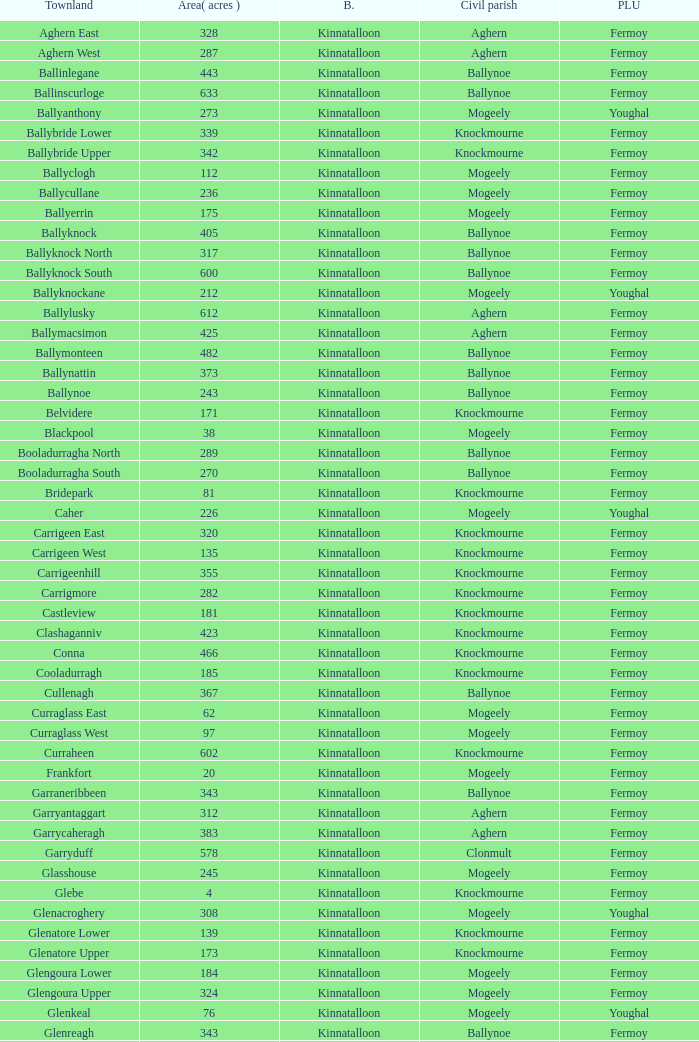Name the area for civil parish ballynoe and killasseragh 340.0. Give me the full table as a dictionary. {'header': ['Townland', 'Area( acres )', 'B.', 'Civil parish', 'PLU'], 'rows': [['Aghern East', '328', 'Kinnatalloon', 'Aghern', 'Fermoy'], ['Aghern West', '287', 'Kinnatalloon', 'Aghern', 'Fermoy'], ['Ballinlegane', '443', 'Kinnatalloon', 'Ballynoe', 'Fermoy'], ['Ballinscurloge', '633', 'Kinnatalloon', 'Ballynoe', 'Fermoy'], ['Ballyanthony', '273', 'Kinnatalloon', 'Mogeely', 'Youghal'], ['Ballybride Lower', '339', 'Kinnatalloon', 'Knockmourne', 'Fermoy'], ['Ballybride Upper', '342', 'Kinnatalloon', 'Knockmourne', 'Fermoy'], ['Ballyclogh', '112', 'Kinnatalloon', 'Mogeely', 'Fermoy'], ['Ballycullane', '236', 'Kinnatalloon', 'Mogeely', 'Fermoy'], ['Ballyerrin', '175', 'Kinnatalloon', 'Mogeely', 'Fermoy'], ['Ballyknock', '405', 'Kinnatalloon', 'Ballynoe', 'Fermoy'], ['Ballyknock North', '317', 'Kinnatalloon', 'Ballynoe', 'Fermoy'], ['Ballyknock South', '600', 'Kinnatalloon', 'Ballynoe', 'Fermoy'], ['Ballyknockane', '212', 'Kinnatalloon', 'Mogeely', 'Youghal'], ['Ballylusky', '612', 'Kinnatalloon', 'Aghern', 'Fermoy'], ['Ballymacsimon', '425', 'Kinnatalloon', 'Aghern', 'Fermoy'], ['Ballymonteen', '482', 'Kinnatalloon', 'Ballynoe', 'Fermoy'], ['Ballynattin', '373', 'Kinnatalloon', 'Ballynoe', 'Fermoy'], ['Ballynoe', '243', 'Kinnatalloon', 'Ballynoe', 'Fermoy'], ['Belvidere', '171', 'Kinnatalloon', 'Knockmourne', 'Fermoy'], ['Blackpool', '38', 'Kinnatalloon', 'Mogeely', 'Fermoy'], ['Booladurragha North', '289', 'Kinnatalloon', 'Ballynoe', 'Fermoy'], ['Booladurragha South', '270', 'Kinnatalloon', 'Ballynoe', 'Fermoy'], ['Bridepark', '81', 'Kinnatalloon', 'Knockmourne', 'Fermoy'], ['Caher', '226', 'Kinnatalloon', 'Mogeely', 'Youghal'], ['Carrigeen East', '320', 'Kinnatalloon', 'Knockmourne', 'Fermoy'], ['Carrigeen West', '135', 'Kinnatalloon', 'Knockmourne', 'Fermoy'], ['Carrigeenhill', '355', 'Kinnatalloon', 'Knockmourne', 'Fermoy'], ['Carrigmore', '282', 'Kinnatalloon', 'Knockmourne', 'Fermoy'], ['Castleview', '181', 'Kinnatalloon', 'Knockmourne', 'Fermoy'], ['Clashaganniv', '423', 'Kinnatalloon', 'Knockmourne', 'Fermoy'], ['Conna', '466', 'Kinnatalloon', 'Knockmourne', 'Fermoy'], ['Cooladurragh', '185', 'Kinnatalloon', 'Knockmourne', 'Fermoy'], ['Cullenagh', '367', 'Kinnatalloon', 'Ballynoe', 'Fermoy'], ['Curraglass East', '62', 'Kinnatalloon', 'Mogeely', 'Fermoy'], ['Curraglass West', '97', 'Kinnatalloon', 'Mogeely', 'Fermoy'], ['Curraheen', '602', 'Kinnatalloon', 'Knockmourne', 'Fermoy'], ['Frankfort', '20', 'Kinnatalloon', 'Mogeely', 'Fermoy'], ['Garraneribbeen', '343', 'Kinnatalloon', 'Ballynoe', 'Fermoy'], ['Garryantaggart', '312', 'Kinnatalloon', 'Aghern', 'Fermoy'], ['Garrycaheragh', '383', 'Kinnatalloon', 'Aghern', 'Fermoy'], ['Garryduff', '578', 'Kinnatalloon', 'Clonmult', 'Fermoy'], ['Glasshouse', '245', 'Kinnatalloon', 'Mogeely', 'Fermoy'], ['Glebe', '4', 'Kinnatalloon', 'Knockmourne', 'Fermoy'], ['Glenacroghery', '308', 'Kinnatalloon', 'Mogeely', 'Youghal'], ['Glenatore Lower', '139', 'Kinnatalloon', 'Knockmourne', 'Fermoy'], ['Glenatore Upper', '173', 'Kinnatalloon', 'Knockmourne', 'Fermoy'], ['Glengoura Lower', '184', 'Kinnatalloon', 'Mogeely', 'Fermoy'], ['Glengoura Upper', '324', 'Kinnatalloon', 'Mogeely', 'Fermoy'], ['Glenkeal', '76', 'Kinnatalloon', 'Mogeely', 'Youghal'], ['Glenreagh', '343', 'Kinnatalloon', 'Ballynoe', 'Fermoy'], ['Glentane', '274', 'Kinnatalloon', 'Ballynoe', 'Fermoy'], ['Glentrasna', '284', 'Kinnatalloon', 'Aghern', 'Fermoy'], ['Glentrasna North', '219', 'Kinnatalloon', 'Aghern', 'Fermoy'], ['Glentrasna South', '220', 'Kinnatalloon', 'Aghern', 'Fermoy'], ['Gortnafira', '78', 'Kinnatalloon', 'Mogeely', 'Fermoy'], ['Inchyallagh', '8', 'Kinnatalloon', 'Mogeely', 'Fermoy'], ['Kilclare Lower', '109', 'Kinnatalloon', 'Knockmourne', 'Fermoy'], ['Kilclare Upper', '493', 'Kinnatalloon', 'Knockmourne', 'Fermoy'], ['Kilcronat', '516', 'Kinnatalloon', 'Mogeely', 'Youghal'], ['Kilcronatmountain', '385', 'Kinnatalloon', 'Mogeely', 'Youghal'], ['Killasseragh', '340', 'Kinnatalloon', 'Ballynoe', 'Fermoy'], ['Killavarilly', '372', 'Kinnatalloon', 'Knockmourne', 'Fermoy'], ['Kilmacow', '316', 'Kinnatalloon', 'Mogeely', 'Fermoy'], ['Kilnafurrery', '256', 'Kinnatalloon', 'Mogeely', 'Youghal'], ['Kilphillibeen', '535', 'Kinnatalloon', 'Ballynoe', 'Fermoy'], ['Knockacool', '404', 'Kinnatalloon', 'Mogeely', 'Youghal'], ['Knockakeo', '296', 'Kinnatalloon', 'Ballynoe', 'Fermoy'], ['Knockanarrig', '215', 'Kinnatalloon', 'Mogeely', 'Youghal'], ['Knockastickane', '164', 'Kinnatalloon', 'Knockmourne', 'Fermoy'], ['Knocknagapple', '293', 'Kinnatalloon', 'Aghern', 'Fermoy'], ['Lackbrack', '84', 'Kinnatalloon', 'Mogeely', 'Fermoy'], ['Lacken', '262', 'Kinnatalloon', 'Mogeely', 'Youghal'], ['Lackenbehy', '101', 'Kinnatalloon', 'Mogeely', 'Fermoy'], ['Limekilnclose', '41', 'Kinnatalloon', 'Mogeely', 'Lismore'], ['Lisnabrin Lower', '114', 'Kinnatalloon', 'Mogeely', 'Fermoy'], ['Lisnabrin North', '217', 'Kinnatalloon', 'Mogeely', 'Fermoy'], ['Lisnabrin South', '180', 'Kinnatalloon', 'Mogeely', 'Fermoy'], ['Lisnabrinlodge', '28', 'Kinnatalloon', 'Mogeely', 'Fermoy'], ['Littlegrace', '50', 'Kinnatalloon', 'Knockmourne', 'Lismore'], ['Longueville North', '355', 'Kinnatalloon', 'Ballynoe', 'Fermoy'], ['Longueville South', '271', 'Kinnatalloon', 'Ballynoe', 'Fermoy'], ['Lyre', '160', 'Kinnatalloon', 'Mogeely', 'Youghal'], ['Lyre Mountain', '360', 'Kinnatalloon', 'Mogeely', 'Youghal'], ['Mogeely Lower', '304', 'Kinnatalloon', 'Mogeely', 'Fermoy'], ['Mogeely Upper', '247', 'Kinnatalloon', 'Mogeely', 'Fermoy'], ['Monagown', '491', 'Kinnatalloon', 'Knockmourne', 'Fermoy'], ['Monaloo', '458', 'Kinnatalloon', 'Mogeely', 'Youghal'], ['Mountprospect', '102', 'Kinnatalloon', 'Mogeely', 'Fermoy'], ['Park', '119', 'Kinnatalloon', 'Aghern', 'Fermoy'], ['Poundfields', '15', 'Kinnatalloon', 'Mogeely', 'Fermoy'], ['Rathdrum', '336', 'Kinnatalloon', 'Ballynoe', 'Fermoy'], ['Rathdrum', '339', 'Kinnatalloon', 'Britway', 'Fermoy'], ['Reanduff', '318', 'Kinnatalloon', 'Mogeely', 'Youghal'], ['Rearour North', '208', 'Kinnatalloon', 'Mogeely', 'Youghal'], ['Rearour South', '223', 'Kinnatalloon', 'Mogeely', 'Youghal'], ['Rosybower', '105', 'Kinnatalloon', 'Mogeely', 'Fermoy'], ['Sandyhill', '263', 'Kinnatalloon', 'Mogeely', 'Youghal'], ['Shanaboola', '190', 'Kinnatalloon', 'Ballynoe', 'Fermoy'], ['Shanakill Lower', '244', 'Kinnatalloon', 'Mogeely', 'Fermoy'], ['Shanakill Upper', '244', 'Kinnatalloon', 'Mogeely', 'Fermoy'], ['Slieveadoctor', '260', 'Kinnatalloon', 'Mogeely', 'Fermoy'], ['Templevally', '330', 'Kinnatalloon', 'Mogeely', 'Fermoy'], ['Vinepark', '7', 'Kinnatalloon', 'Mogeely', 'Fermoy']]} 